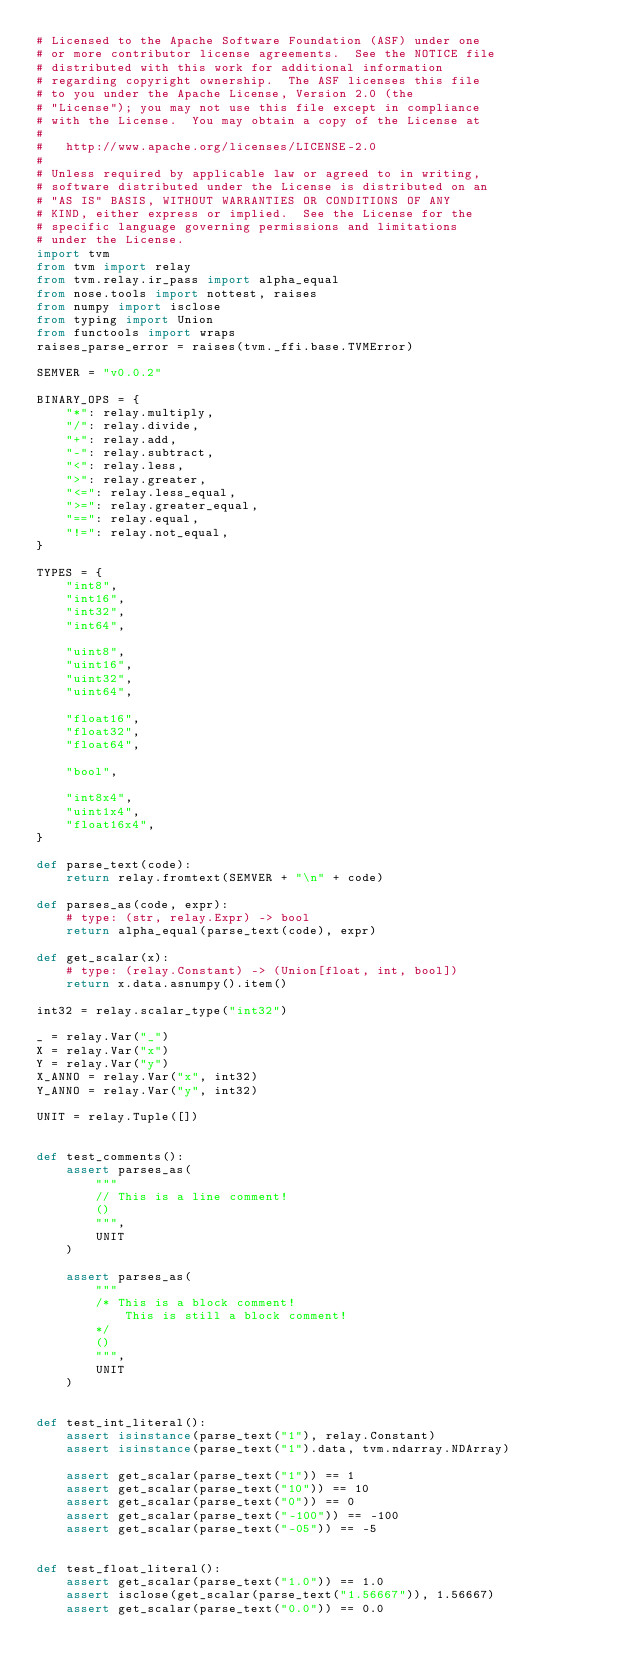<code> <loc_0><loc_0><loc_500><loc_500><_Python_># Licensed to the Apache Software Foundation (ASF) under one
# or more contributor license agreements.  See the NOTICE file
# distributed with this work for additional information
# regarding copyright ownership.  The ASF licenses this file
# to you under the Apache License, Version 2.0 (the
# "License"); you may not use this file except in compliance
# with the License.  You may obtain a copy of the License at
#
#   http://www.apache.org/licenses/LICENSE-2.0
#
# Unless required by applicable law or agreed to in writing,
# software distributed under the License is distributed on an
# "AS IS" BASIS, WITHOUT WARRANTIES OR CONDITIONS OF ANY
# KIND, either express or implied.  See the License for the
# specific language governing permissions and limitations
# under the License.
import tvm
from tvm import relay
from tvm.relay.ir_pass import alpha_equal
from nose.tools import nottest, raises
from numpy import isclose
from typing import Union
from functools import wraps
raises_parse_error = raises(tvm._ffi.base.TVMError)

SEMVER = "v0.0.2"

BINARY_OPS = {
    "*": relay.multiply,
    "/": relay.divide,
    "+": relay.add,
    "-": relay.subtract,
    "<": relay.less,
    ">": relay.greater,
    "<=": relay.less_equal,
    ">=": relay.greater_equal,
    "==": relay.equal,
    "!=": relay.not_equal,
}

TYPES = {
    "int8",
    "int16",
    "int32",
    "int64",

    "uint8",
    "uint16",
    "uint32",
    "uint64",

    "float16",
    "float32",
    "float64",

    "bool",

    "int8x4",
    "uint1x4",
    "float16x4",
}

def parse_text(code):
    return relay.fromtext(SEMVER + "\n" + code)

def parses_as(code, expr):
    # type: (str, relay.Expr) -> bool
    return alpha_equal(parse_text(code), expr)

def get_scalar(x):
    # type: (relay.Constant) -> (Union[float, int, bool])
    return x.data.asnumpy().item()

int32 = relay.scalar_type("int32")

_ = relay.Var("_")
X = relay.Var("x")
Y = relay.Var("y")
X_ANNO = relay.Var("x", int32)
Y_ANNO = relay.Var("y", int32)

UNIT = relay.Tuple([])


def test_comments():
    assert parses_as(
        """
        // This is a line comment!
        ()
        """,
        UNIT
    )

    assert parses_as(
        """
        /* This is a block comment!
            This is still a block comment!
        */
        ()
        """,
        UNIT
    )


def test_int_literal():
    assert isinstance(parse_text("1"), relay.Constant)
    assert isinstance(parse_text("1").data, tvm.ndarray.NDArray)

    assert get_scalar(parse_text("1")) == 1
    assert get_scalar(parse_text("10")) == 10
    assert get_scalar(parse_text("0")) == 0
    assert get_scalar(parse_text("-100")) == -100
    assert get_scalar(parse_text("-05")) == -5


def test_float_literal():
    assert get_scalar(parse_text("1.0")) == 1.0
    assert isclose(get_scalar(parse_text("1.56667")), 1.56667)
    assert get_scalar(parse_text("0.0")) == 0.0</code> 